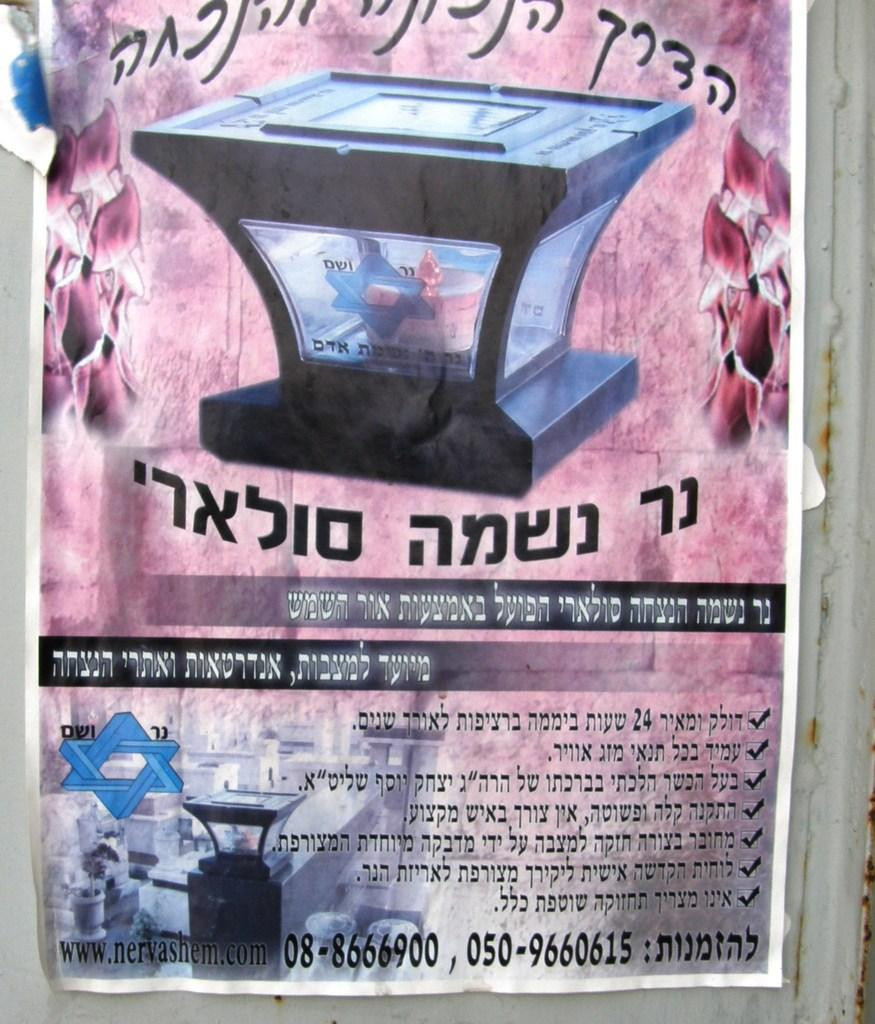What is present in the image related to advertising or information? There is a poster in the image. What color is the poster? The poster is pink in color. What can be found on the poster besides the color? There is text on the poster. Can you tell me how many buttons are on the poster in the image? There are no buttons present on the poster in the image. What type of work is being advertised on the poster? The image does not provide any information about the type of work being advertised, as there is no reference to work or any specific job in the provided facts. 